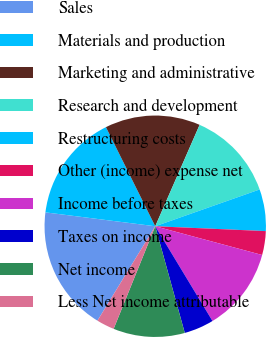Convert chart. <chart><loc_0><loc_0><loc_500><loc_500><pie_chart><fcel>Sales<fcel>Materials and production<fcel>Marketing and administrative<fcel>Research and development<fcel>Restructuring costs<fcel>Other (income) expense net<fcel>Income before taxes<fcel>Taxes on income<fcel>Net income<fcel>Less Net income attributable<nl><fcel>18.26%<fcel>15.65%<fcel>13.91%<fcel>13.04%<fcel>6.09%<fcel>3.48%<fcel>12.17%<fcel>4.35%<fcel>10.43%<fcel>2.61%<nl></chart> 